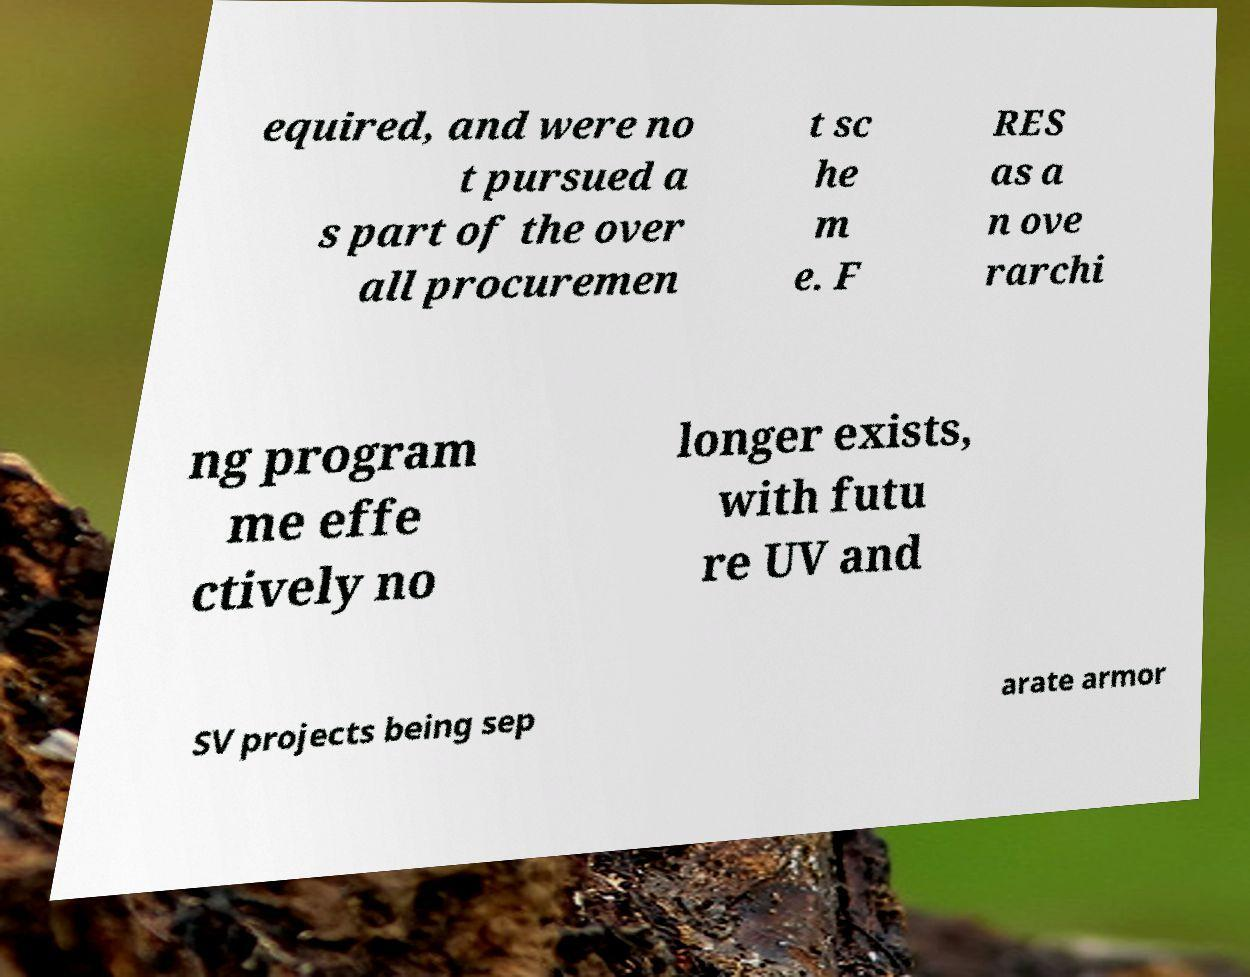Can you read and provide the text displayed in the image?This photo seems to have some interesting text. Can you extract and type it out for me? equired, and were no t pursued a s part of the over all procuremen t sc he m e. F RES as a n ove rarchi ng program me effe ctively no longer exists, with futu re UV and SV projects being sep arate armor 